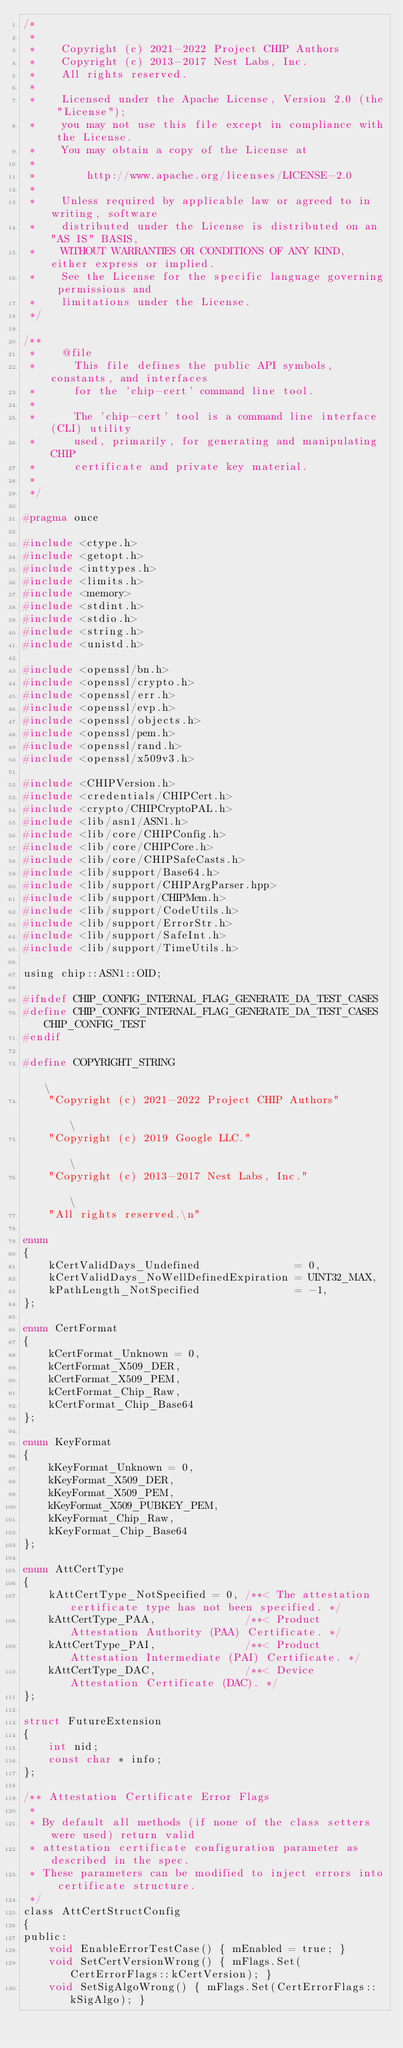Convert code to text. <code><loc_0><loc_0><loc_500><loc_500><_C_>/*
 *
 *    Copyright (c) 2021-2022 Project CHIP Authors
 *    Copyright (c) 2013-2017 Nest Labs, Inc.
 *    All rights reserved.
 *
 *    Licensed under the Apache License, Version 2.0 (the "License");
 *    you may not use this file except in compliance with the License.
 *    You may obtain a copy of the License at
 *
 *        http://www.apache.org/licenses/LICENSE-2.0
 *
 *    Unless required by applicable law or agreed to in writing, software
 *    distributed under the License is distributed on an "AS IS" BASIS,
 *    WITHOUT WARRANTIES OR CONDITIONS OF ANY KIND, either express or implied.
 *    See the License for the specific language governing permissions and
 *    limitations under the License.
 */

/**
 *    @file
 *      This file defines the public API symbols, constants, and interfaces
 *      for the 'chip-cert' command line tool.
 *
 *      The 'chip-cert' tool is a command line interface (CLI) utility
 *      used, primarily, for generating and manipulating CHIP
 *      certificate and private key material.
 *
 */

#pragma once

#include <ctype.h>
#include <getopt.h>
#include <inttypes.h>
#include <limits.h>
#include <memory>
#include <stdint.h>
#include <stdio.h>
#include <string.h>
#include <unistd.h>

#include <openssl/bn.h>
#include <openssl/crypto.h>
#include <openssl/err.h>
#include <openssl/evp.h>
#include <openssl/objects.h>
#include <openssl/pem.h>
#include <openssl/rand.h>
#include <openssl/x509v3.h>

#include <CHIPVersion.h>
#include <credentials/CHIPCert.h>
#include <crypto/CHIPCryptoPAL.h>
#include <lib/asn1/ASN1.h>
#include <lib/core/CHIPConfig.h>
#include <lib/core/CHIPCore.h>
#include <lib/core/CHIPSafeCasts.h>
#include <lib/support/Base64.h>
#include <lib/support/CHIPArgParser.hpp>
#include <lib/support/CHIPMem.h>
#include <lib/support/CodeUtils.h>
#include <lib/support/ErrorStr.h>
#include <lib/support/SafeInt.h>
#include <lib/support/TimeUtils.h>

using chip::ASN1::OID;

#ifndef CHIP_CONFIG_INTERNAL_FLAG_GENERATE_DA_TEST_CASES
#define CHIP_CONFIG_INTERNAL_FLAG_GENERATE_DA_TEST_CASES CHIP_CONFIG_TEST
#endif

#define COPYRIGHT_STRING                                                                                                           \
    "Copyright (c) 2021-2022 Project CHIP Authors"                                                                                 \
    "Copyright (c) 2019 Google LLC."                                                                                               \
    "Copyright (c) 2013-2017 Nest Labs, Inc."                                                                                      \
    "All rights reserved.\n"

enum
{
    kCertValidDays_Undefined               = 0,
    kCertValidDays_NoWellDefinedExpiration = UINT32_MAX,
    kPathLength_NotSpecified               = -1,
};

enum CertFormat
{
    kCertFormat_Unknown = 0,
    kCertFormat_X509_DER,
    kCertFormat_X509_PEM,
    kCertFormat_Chip_Raw,
    kCertFormat_Chip_Base64
};

enum KeyFormat
{
    kKeyFormat_Unknown = 0,
    kKeyFormat_X509_DER,
    kKeyFormat_X509_PEM,
    kKeyFormat_X509_PUBKEY_PEM,
    kKeyFormat_Chip_Raw,
    kKeyFormat_Chip_Base64
};

enum AttCertType
{
    kAttCertType_NotSpecified = 0, /**< The attestation certificate type has not been specified. */
    kAttCertType_PAA,              /**< Product Attestation Authority (PAA) Certificate. */
    kAttCertType_PAI,              /**< Product Attestation Intermediate (PAI) Certificate. */
    kAttCertType_DAC,              /**< Device Attestation Certificate (DAC). */
};

struct FutureExtension
{
    int nid;
    const char * info;
};

/** Attestation Certificate Error Flags
 *
 * By default all methods (if none of the class setters were used) return valid
 * attestation certificate configuration parameter as described in the spec.
 * These parameters can be modified to inject errors into certificate structure.
 */
class AttCertStructConfig
{
public:
    void EnableErrorTestCase() { mEnabled = true; }
    void SetCertVersionWrong() { mFlags.Set(CertErrorFlags::kCertVersion); }
    void SetSigAlgoWrong() { mFlags.Set(CertErrorFlags::kSigAlgo); }</code> 